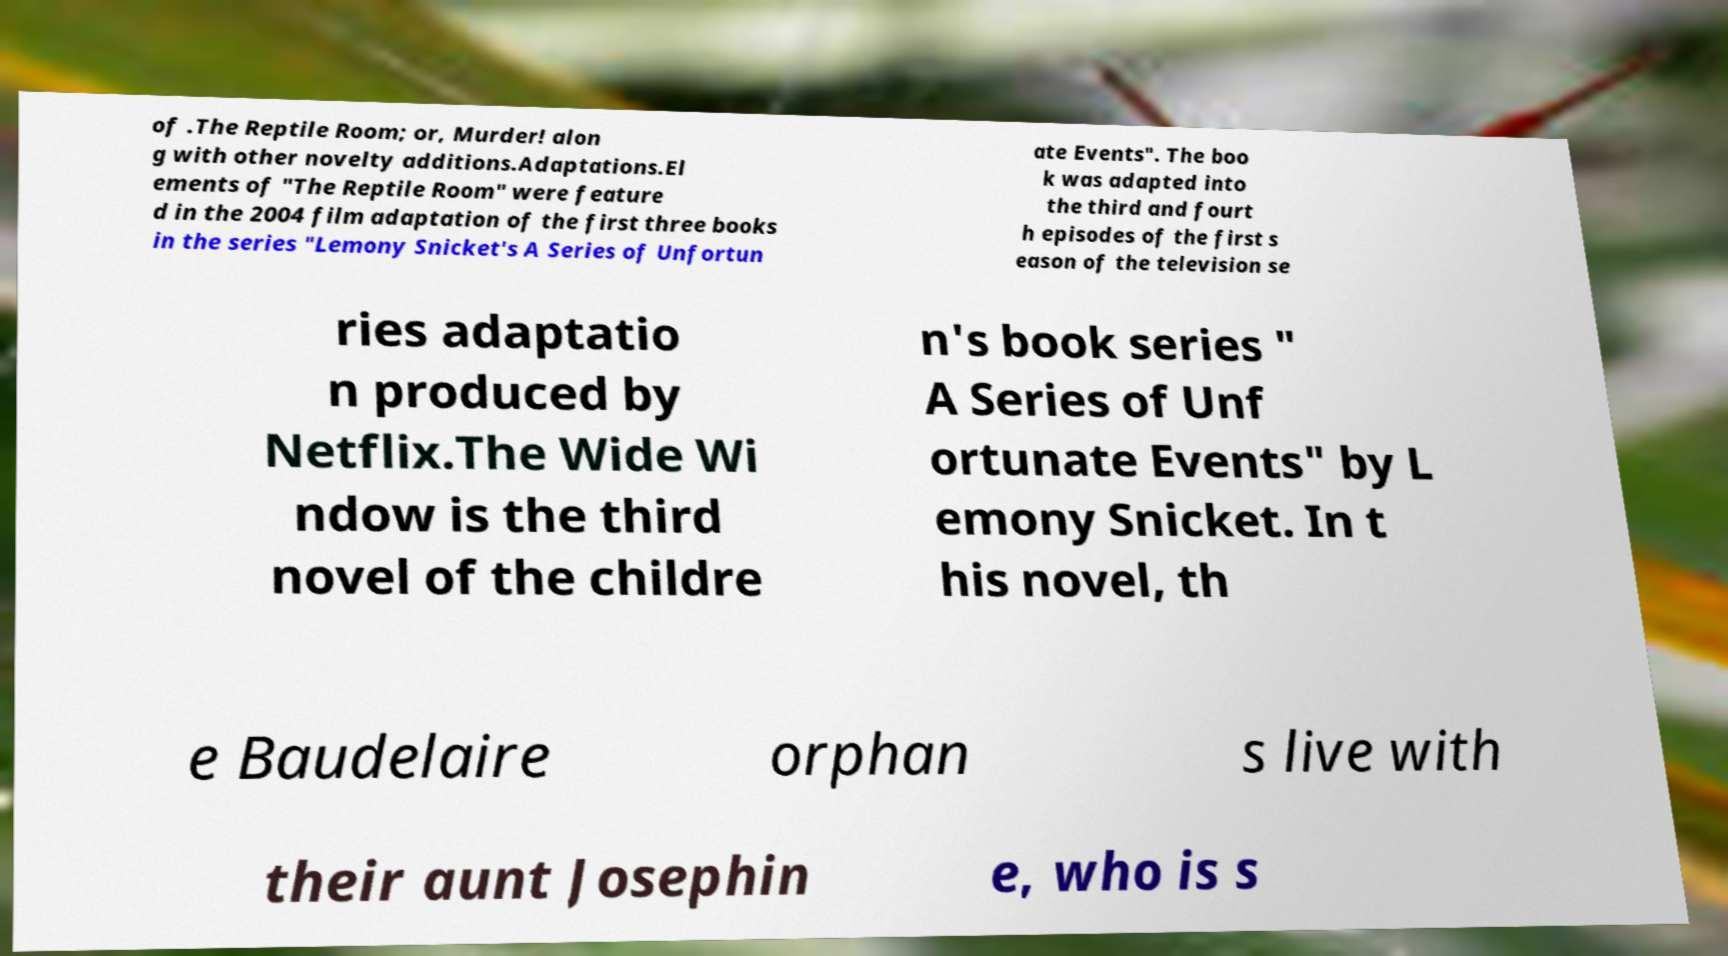Could you assist in decoding the text presented in this image and type it out clearly? of .The Reptile Room; or, Murder! alon g with other novelty additions.Adaptations.El ements of "The Reptile Room" were feature d in the 2004 film adaptation of the first three books in the series "Lemony Snicket's A Series of Unfortun ate Events". The boo k was adapted into the third and fourt h episodes of the first s eason of the television se ries adaptatio n produced by Netflix.The Wide Wi ndow is the third novel of the childre n's book series " A Series of Unf ortunate Events" by L emony Snicket. In t his novel, th e Baudelaire orphan s live with their aunt Josephin e, who is s 